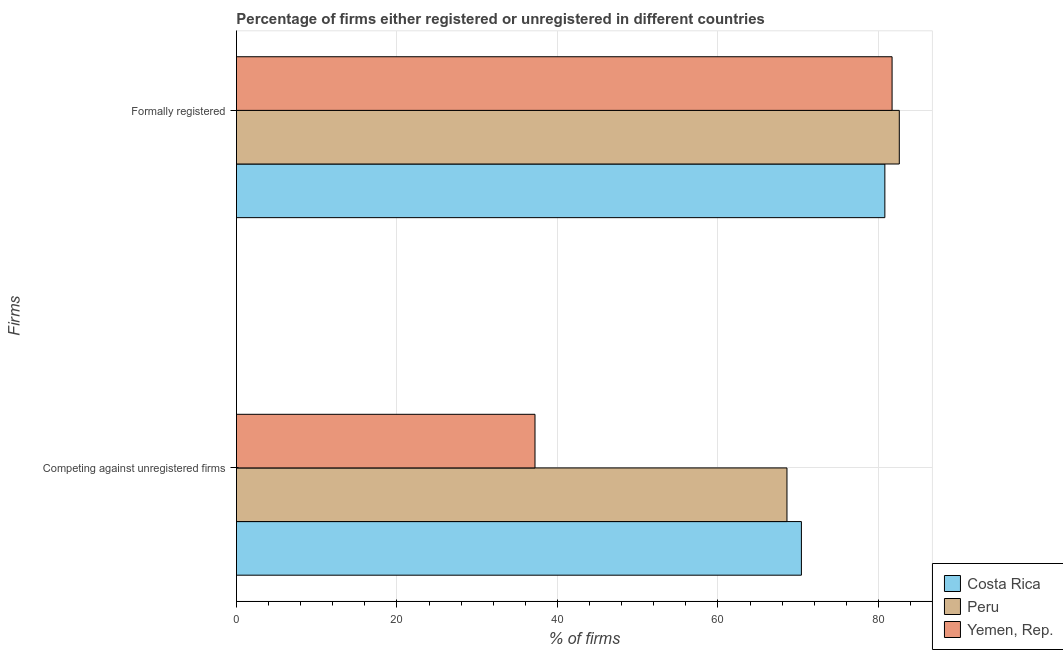How many groups of bars are there?
Your answer should be compact. 2. Are the number of bars per tick equal to the number of legend labels?
Make the answer very short. Yes. Are the number of bars on each tick of the Y-axis equal?
Offer a terse response. Yes. How many bars are there on the 1st tick from the top?
Give a very brief answer. 3. How many bars are there on the 2nd tick from the bottom?
Keep it short and to the point. 3. What is the label of the 2nd group of bars from the top?
Your answer should be very brief. Competing against unregistered firms. What is the percentage of registered firms in Peru?
Make the answer very short. 68.6. Across all countries, what is the maximum percentage of formally registered firms?
Make the answer very short. 82.6. Across all countries, what is the minimum percentage of formally registered firms?
Offer a very short reply. 80.8. In which country was the percentage of formally registered firms minimum?
Your answer should be compact. Costa Rica. What is the total percentage of registered firms in the graph?
Your answer should be compact. 176.2. What is the difference between the percentage of formally registered firms in Peru and that in Costa Rica?
Give a very brief answer. 1.8. What is the difference between the percentage of registered firms in Costa Rica and the percentage of formally registered firms in Yemen, Rep.?
Ensure brevity in your answer.  -11.3. What is the average percentage of registered firms per country?
Give a very brief answer. 58.73. What is the difference between the percentage of formally registered firms and percentage of registered firms in Costa Rica?
Your answer should be compact. 10.4. In how many countries, is the percentage of registered firms greater than 24 %?
Give a very brief answer. 3. What is the ratio of the percentage of registered firms in Yemen, Rep. to that in Peru?
Your answer should be very brief. 0.54. What does the 1st bar from the top in Competing against unregistered firms represents?
Ensure brevity in your answer.  Yemen, Rep. What does the 3rd bar from the bottom in Competing against unregistered firms represents?
Your answer should be very brief. Yemen, Rep. How many bars are there?
Your response must be concise. 6. Are all the bars in the graph horizontal?
Give a very brief answer. Yes. How many countries are there in the graph?
Keep it short and to the point. 3. What is the difference between two consecutive major ticks on the X-axis?
Offer a terse response. 20. Are the values on the major ticks of X-axis written in scientific E-notation?
Give a very brief answer. No. Does the graph contain any zero values?
Provide a short and direct response. No. How many legend labels are there?
Give a very brief answer. 3. What is the title of the graph?
Your answer should be compact. Percentage of firms either registered or unregistered in different countries. What is the label or title of the X-axis?
Make the answer very short. % of firms. What is the label or title of the Y-axis?
Offer a very short reply. Firms. What is the % of firms in Costa Rica in Competing against unregistered firms?
Give a very brief answer. 70.4. What is the % of firms in Peru in Competing against unregistered firms?
Your answer should be very brief. 68.6. What is the % of firms in Yemen, Rep. in Competing against unregistered firms?
Offer a terse response. 37.2. What is the % of firms of Costa Rica in Formally registered?
Your answer should be compact. 80.8. What is the % of firms in Peru in Formally registered?
Provide a succinct answer. 82.6. What is the % of firms of Yemen, Rep. in Formally registered?
Your response must be concise. 81.7. Across all Firms, what is the maximum % of firms in Costa Rica?
Offer a terse response. 80.8. Across all Firms, what is the maximum % of firms of Peru?
Make the answer very short. 82.6. Across all Firms, what is the maximum % of firms of Yemen, Rep.?
Keep it short and to the point. 81.7. Across all Firms, what is the minimum % of firms of Costa Rica?
Your response must be concise. 70.4. Across all Firms, what is the minimum % of firms in Peru?
Keep it short and to the point. 68.6. Across all Firms, what is the minimum % of firms of Yemen, Rep.?
Provide a short and direct response. 37.2. What is the total % of firms of Costa Rica in the graph?
Make the answer very short. 151.2. What is the total % of firms in Peru in the graph?
Provide a short and direct response. 151.2. What is the total % of firms in Yemen, Rep. in the graph?
Your answer should be very brief. 118.9. What is the difference between the % of firms in Yemen, Rep. in Competing against unregistered firms and that in Formally registered?
Your answer should be very brief. -44.5. What is the difference between the % of firms of Costa Rica in Competing against unregistered firms and the % of firms of Peru in Formally registered?
Make the answer very short. -12.2. What is the difference between the % of firms in Costa Rica in Competing against unregistered firms and the % of firms in Yemen, Rep. in Formally registered?
Keep it short and to the point. -11.3. What is the average % of firms of Costa Rica per Firms?
Keep it short and to the point. 75.6. What is the average % of firms of Peru per Firms?
Give a very brief answer. 75.6. What is the average % of firms of Yemen, Rep. per Firms?
Your answer should be compact. 59.45. What is the difference between the % of firms of Costa Rica and % of firms of Peru in Competing against unregistered firms?
Give a very brief answer. 1.8. What is the difference between the % of firms in Costa Rica and % of firms in Yemen, Rep. in Competing against unregistered firms?
Make the answer very short. 33.2. What is the difference between the % of firms in Peru and % of firms in Yemen, Rep. in Competing against unregistered firms?
Provide a succinct answer. 31.4. What is the difference between the % of firms in Costa Rica and % of firms in Peru in Formally registered?
Provide a short and direct response. -1.8. What is the difference between the % of firms of Costa Rica and % of firms of Yemen, Rep. in Formally registered?
Make the answer very short. -0.9. What is the ratio of the % of firms of Costa Rica in Competing against unregistered firms to that in Formally registered?
Provide a succinct answer. 0.87. What is the ratio of the % of firms in Peru in Competing against unregistered firms to that in Formally registered?
Make the answer very short. 0.83. What is the ratio of the % of firms in Yemen, Rep. in Competing against unregistered firms to that in Formally registered?
Offer a very short reply. 0.46. What is the difference between the highest and the second highest % of firms in Peru?
Ensure brevity in your answer.  14. What is the difference between the highest and the second highest % of firms of Yemen, Rep.?
Your answer should be compact. 44.5. What is the difference between the highest and the lowest % of firms of Peru?
Provide a short and direct response. 14. What is the difference between the highest and the lowest % of firms of Yemen, Rep.?
Keep it short and to the point. 44.5. 